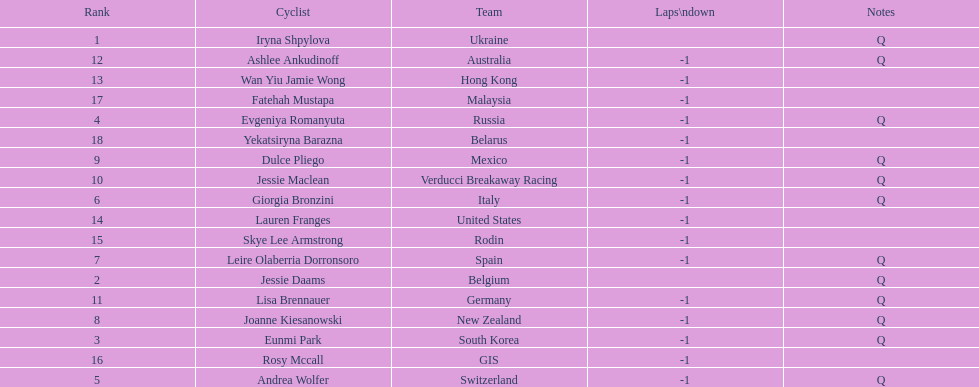How many cyclist do not have -1 laps down? 2. 